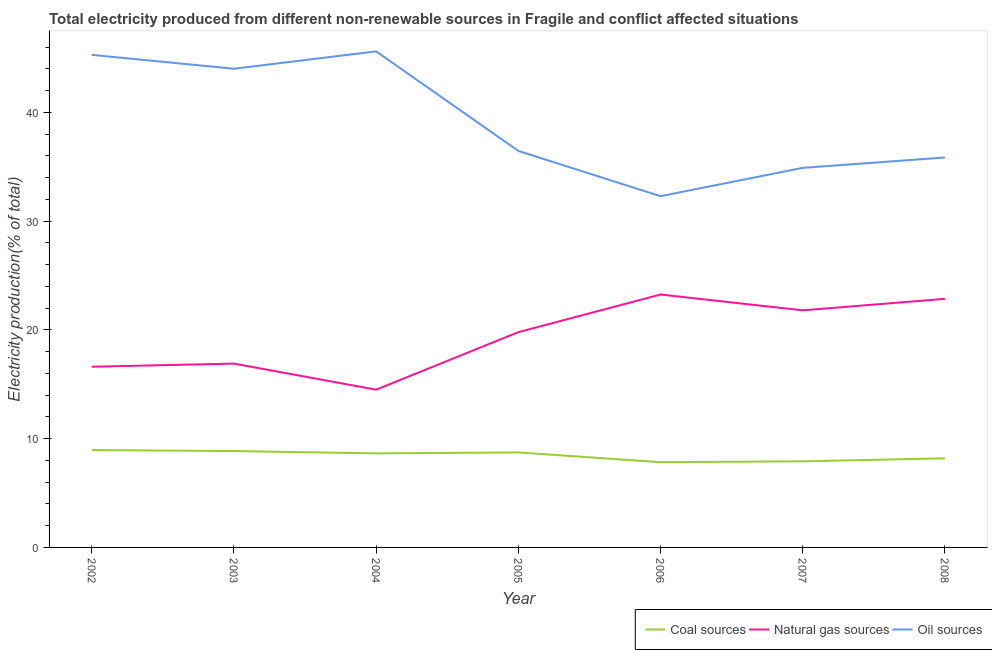What is the percentage of electricity produced by oil sources in 2004?
Give a very brief answer. 45.6. Across all years, what is the maximum percentage of electricity produced by coal?
Give a very brief answer. 8.95. Across all years, what is the minimum percentage of electricity produced by natural gas?
Offer a very short reply. 14.5. In which year was the percentage of electricity produced by natural gas minimum?
Offer a terse response. 2004. What is the total percentage of electricity produced by natural gas in the graph?
Your answer should be very brief. 135.7. What is the difference between the percentage of electricity produced by coal in 2003 and that in 2006?
Give a very brief answer. 1.02. What is the difference between the percentage of electricity produced by coal in 2008 and the percentage of electricity produced by natural gas in 2005?
Keep it short and to the point. -11.6. What is the average percentage of electricity produced by natural gas per year?
Offer a very short reply. 19.39. In the year 2003, what is the difference between the percentage of electricity produced by oil sources and percentage of electricity produced by coal?
Your answer should be very brief. 35.15. In how many years, is the percentage of electricity produced by coal greater than 30 %?
Your answer should be compact. 0. What is the ratio of the percentage of electricity produced by natural gas in 2005 to that in 2007?
Keep it short and to the point. 0.91. Is the percentage of electricity produced by coal in 2004 less than that in 2005?
Your answer should be very brief. Yes. Is the difference between the percentage of electricity produced by natural gas in 2003 and 2007 greater than the difference between the percentage of electricity produced by coal in 2003 and 2007?
Provide a succinct answer. No. What is the difference between the highest and the second highest percentage of electricity produced by coal?
Provide a short and direct response. 0.09. What is the difference between the highest and the lowest percentage of electricity produced by natural gas?
Keep it short and to the point. 8.75. In how many years, is the percentage of electricity produced by natural gas greater than the average percentage of electricity produced by natural gas taken over all years?
Keep it short and to the point. 4. Is it the case that in every year, the sum of the percentage of electricity produced by coal and percentage of electricity produced by natural gas is greater than the percentage of electricity produced by oil sources?
Offer a very short reply. No. Does the percentage of electricity produced by coal monotonically increase over the years?
Your answer should be compact. No. Is the percentage of electricity produced by natural gas strictly greater than the percentage of electricity produced by oil sources over the years?
Ensure brevity in your answer.  No. Is the percentage of electricity produced by natural gas strictly less than the percentage of electricity produced by coal over the years?
Your answer should be very brief. No. Does the graph contain any zero values?
Provide a succinct answer. No. What is the title of the graph?
Provide a short and direct response. Total electricity produced from different non-renewable sources in Fragile and conflict affected situations. What is the Electricity production(% of total) in Coal sources in 2002?
Offer a terse response. 8.95. What is the Electricity production(% of total) in Natural gas sources in 2002?
Keep it short and to the point. 16.61. What is the Electricity production(% of total) of Oil sources in 2002?
Your answer should be compact. 45.28. What is the Electricity production(% of total) in Coal sources in 2003?
Your answer should be compact. 8.86. What is the Electricity production(% of total) of Natural gas sources in 2003?
Offer a very short reply. 16.9. What is the Electricity production(% of total) in Oil sources in 2003?
Ensure brevity in your answer.  44.01. What is the Electricity production(% of total) in Coal sources in 2004?
Your answer should be compact. 8.65. What is the Electricity production(% of total) in Natural gas sources in 2004?
Offer a very short reply. 14.5. What is the Electricity production(% of total) of Oil sources in 2004?
Your answer should be very brief. 45.6. What is the Electricity production(% of total) of Coal sources in 2005?
Make the answer very short. 8.73. What is the Electricity production(% of total) of Natural gas sources in 2005?
Offer a terse response. 19.79. What is the Electricity production(% of total) in Oil sources in 2005?
Keep it short and to the point. 36.45. What is the Electricity production(% of total) in Coal sources in 2006?
Your answer should be compact. 7.84. What is the Electricity production(% of total) of Natural gas sources in 2006?
Give a very brief answer. 23.25. What is the Electricity production(% of total) of Oil sources in 2006?
Your answer should be very brief. 32.29. What is the Electricity production(% of total) in Coal sources in 2007?
Offer a very short reply. 7.91. What is the Electricity production(% of total) of Natural gas sources in 2007?
Provide a succinct answer. 21.8. What is the Electricity production(% of total) of Oil sources in 2007?
Ensure brevity in your answer.  34.89. What is the Electricity production(% of total) in Coal sources in 2008?
Provide a short and direct response. 8.19. What is the Electricity production(% of total) of Natural gas sources in 2008?
Make the answer very short. 22.85. What is the Electricity production(% of total) of Oil sources in 2008?
Your answer should be compact. 35.85. Across all years, what is the maximum Electricity production(% of total) of Coal sources?
Provide a short and direct response. 8.95. Across all years, what is the maximum Electricity production(% of total) of Natural gas sources?
Make the answer very short. 23.25. Across all years, what is the maximum Electricity production(% of total) of Oil sources?
Offer a very short reply. 45.6. Across all years, what is the minimum Electricity production(% of total) of Coal sources?
Provide a succinct answer. 7.84. Across all years, what is the minimum Electricity production(% of total) in Natural gas sources?
Provide a succinct answer. 14.5. Across all years, what is the minimum Electricity production(% of total) of Oil sources?
Your answer should be compact. 32.29. What is the total Electricity production(% of total) of Coal sources in the graph?
Offer a terse response. 59.14. What is the total Electricity production(% of total) of Natural gas sources in the graph?
Your response must be concise. 135.7. What is the total Electricity production(% of total) in Oil sources in the graph?
Give a very brief answer. 274.37. What is the difference between the Electricity production(% of total) in Coal sources in 2002 and that in 2003?
Offer a very short reply. 0.09. What is the difference between the Electricity production(% of total) of Natural gas sources in 2002 and that in 2003?
Give a very brief answer. -0.29. What is the difference between the Electricity production(% of total) in Oil sources in 2002 and that in 2003?
Provide a succinct answer. 1.28. What is the difference between the Electricity production(% of total) in Coal sources in 2002 and that in 2004?
Offer a very short reply. 0.3. What is the difference between the Electricity production(% of total) of Natural gas sources in 2002 and that in 2004?
Give a very brief answer. 2.11. What is the difference between the Electricity production(% of total) of Oil sources in 2002 and that in 2004?
Give a very brief answer. -0.32. What is the difference between the Electricity production(% of total) of Coal sources in 2002 and that in 2005?
Ensure brevity in your answer.  0.22. What is the difference between the Electricity production(% of total) in Natural gas sources in 2002 and that in 2005?
Your answer should be very brief. -3.18. What is the difference between the Electricity production(% of total) of Oil sources in 2002 and that in 2005?
Give a very brief answer. 8.83. What is the difference between the Electricity production(% of total) in Coal sources in 2002 and that in 2006?
Your answer should be very brief. 1.11. What is the difference between the Electricity production(% of total) in Natural gas sources in 2002 and that in 2006?
Offer a terse response. -6.64. What is the difference between the Electricity production(% of total) in Oil sources in 2002 and that in 2006?
Give a very brief answer. 12.99. What is the difference between the Electricity production(% of total) in Coal sources in 2002 and that in 2007?
Offer a terse response. 1.04. What is the difference between the Electricity production(% of total) of Natural gas sources in 2002 and that in 2007?
Offer a terse response. -5.18. What is the difference between the Electricity production(% of total) in Oil sources in 2002 and that in 2007?
Offer a very short reply. 10.39. What is the difference between the Electricity production(% of total) of Coal sources in 2002 and that in 2008?
Provide a succinct answer. 0.76. What is the difference between the Electricity production(% of total) in Natural gas sources in 2002 and that in 2008?
Offer a terse response. -6.24. What is the difference between the Electricity production(% of total) of Oil sources in 2002 and that in 2008?
Provide a succinct answer. 9.43. What is the difference between the Electricity production(% of total) in Coal sources in 2003 and that in 2004?
Ensure brevity in your answer.  0.21. What is the difference between the Electricity production(% of total) in Natural gas sources in 2003 and that in 2004?
Ensure brevity in your answer.  2.4. What is the difference between the Electricity production(% of total) in Oil sources in 2003 and that in 2004?
Provide a short and direct response. -1.6. What is the difference between the Electricity production(% of total) of Coal sources in 2003 and that in 2005?
Provide a succinct answer. 0.13. What is the difference between the Electricity production(% of total) of Natural gas sources in 2003 and that in 2005?
Make the answer very short. -2.89. What is the difference between the Electricity production(% of total) of Oil sources in 2003 and that in 2005?
Your response must be concise. 7.56. What is the difference between the Electricity production(% of total) in Natural gas sources in 2003 and that in 2006?
Make the answer very short. -6.35. What is the difference between the Electricity production(% of total) in Oil sources in 2003 and that in 2006?
Keep it short and to the point. 11.72. What is the difference between the Electricity production(% of total) of Coal sources in 2003 and that in 2007?
Provide a short and direct response. 0.94. What is the difference between the Electricity production(% of total) in Natural gas sources in 2003 and that in 2007?
Make the answer very short. -4.9. What is the difference between the Electricity production(% of total) in Oil sources in 2003 and that in 2007?
Provide a short and direct response. 9.11. What is the difference between the Electricity production(% of total) of Coal sources in 2003 and that in 2008?
Give a very brief answer. 0.67. What is the difference between the Electricity production(% of total) of Natural gas sources in 2003 and that in 2008?
Make the answer very short. -5.95. What is the difference between the Electricity production(% of total) in Oil sources in 2003 and that in 2008?
Keep it short and to the point. 8.16. What is the difference between the Electricity production(% of total) of Coal sources in 2004 and that in 2005?
Ensure brevity in your answer.  -0.08. What is the difference between the Electricity production(% of total) of Natural gas sources in 2004 and that in 2005?
Offer a very short reply. -5.29. What is the difference between the Electricity production(% of total) in Oil sources in 2004 and that in 2005?
Your answer should be very brief. 9.15. What is the difference between the Electricity production(% of total) in Coal sources in 2004 and that in 2006?
Offer a terse response. 0.81. What is the difference between the Electricity production(% of total) of Natural gas sources in 2004 and that in 2006?
Keep it short and to the point. -8.75. What is the difference between the Electricity production(% of total) in Oil sources in 2004 and that in 2006?
Provide a short and direct response. 13.31. What is the difference between the Electricity production(% of total) in Coal sources in 2004 and that in 2007?
Provide a succinct answer. 0.73. What is the difference between the Electricity production(% of total) of Natural gas sources in 2004 and that in 2007?
Your response must be concise. -7.29. What is the difference between the Electricity production(% of total) in Oil sources in 2004 and that in 2007?
Offer a terse response. 10.71. What is the difference between the Electricity production(% of total) in Coal sources in 2004 and that in 2008?
Make the answer very short. 0.46. What is the difference between the Electricity production(% of total) in Natural gas sources in 2004 and that in 2008?
Keep it short and to the point. -8.35. What is the difference between the Electricity production(% of total) in Oil sources in 2004 and that in 2008?
Offer a very short reply. 9.76. What is the difference between the Electricity production(% of total) of Coal sources in 2005 and that in 2006?
Offer a very short reply. 0.89. What is the difference between the Electricity production(% of total) in Natural gas sources in 2005 and that in 2006?
Your response must be concise. -3.46. What is the difference between the Electricity production(% of total) in Oil sources in 2005 and that in 2006?
Offer a terse response. 4.16. What is the difference between the Electricity production(% of total) of Coal sources in 2005 and that in 2007?
Offer a terse response. 0.82. What is the difference between the Electricity production(% of total) in Natural gas sources in 2005 and that in 2007?
Provide a short and direct response. -2.01. What is the difference between the Electricity production(% of total) in Oil sources in 2005 and that in 2007?
Provide a short and direct response. 1.56. What is the difference between the Electricity production(% of total) in Coal sources in 2005 and that in 2008?
Ensure brevity in your answer.  0.54. What is the difference between the Electricity production(% of total) in Natural gas sources in 2005 and that in 2008?
Keep it short and to the point. -3.06. What is the difference between the Electricity production(% of total) of Oil sources in 2005 and that in 2008?
Your answer should be compact. 0.6. What is the difference between the Electricity production(% of total) in Coal sources in 2006 and that in 2007?
Provide a short and direct response. -0.08. What is the difference between the Electricity production(% of total) of Natural gas sources in 2006 and that in 2007?
Offer a very short reply. 1.45. What is the difference between the Electricity production(% of total) of Oil sources in 2006 and that in 2007?
Your response must be concise. -2.6. What is the difference between the Electricity production(% of total) in Coal sources in 2006 and that in 2008?
Provide a short and direct response. -0.35. What is the difference between the Electricity production(% of total) of Natural gas sources in 2006 and that in 2008?
Your answer should be compact. 0.4. What is the difference between the Electricity production(% of total) of Oil sources in 2006 and that in 2008?
Your response must be concise. -3.56. What is the difference between the Electricity production(% of total) in Coal sources in 2007 and that in 2008?
Your response must be concise. -0.28. What is the difference between the Electricity production(% of total) of Natural gas sources in 2007 and that in 2008?
Ensure brevity in your answer.  -1.05. What is the difference between the Electricity production(% of total) of Oil sources in 2007 and that in 2008?
Keep it short and to the point. -0.95. What is the difference between the Electricity production(% of total) in Coal sources in 2002 and the Electricity production(% of total) in Natural gas sources in 2003?
Provide a succinct answer. -7.95. What is the difference between the Electricity production(% of total) of Coal sources in 2002 and the Electricity production(% of total) of Oil sources in 2003?
Ensure brevity in your answer.  -35.05. What is the difference between the Electricity production(% of total) of Natural gas sources in 2002 and the Electricity production(% of total) of Oil sources in 2003?
Your answer should be very brief. -27.39. What is the difference between the Electricity production(% of total) in Coal sources in 2002 and the Electricity production(% of total) in Natural gas sources in 2004?
Provide a succinct answer. -5.55. What is the difference between the Electricity production(% of total) in Coal sources in 2002 and the Electricity production(% of total) in Oil sources in 2004?
Ensure brevity in your answer.  -36.65. What is the difference between the Electricity production(% of total) of Natural gas sources in 2002 and the Electricity production(% of total) of Oil sources in 2004?
Offer a very short reply. -28.99. What is the difference between the Electricity production(% of total) in Coal sources in 2002 and the Electricity production(% of total) in Natural gas sources in 2005?
Your response must be concise. -10.84. What is the difference between the Electricity production(% of total) of Coal sources in 2002 and the Electricity production(% of total) of Oil sources in 2005?
Offer a terse response. -27.5. What is the difference between the Electricity production(% of total) of Natural gas sources in 2002 and the Electricity production(% of total) of Oil sources in 2005?
Keep it short and to the point. -19.84. What is the difference between the Electricity production(% of total) of Coal sources in 2002 and the Electricity production(% of total) of Natural gas sources in 2006?
Your answer should be very brief. -14.3. What is the difference between the Electricity production(% of total) of Coal sources in 2002 and the Electricity production(% of total) of Oil sources in 2006?
Your response must be concise. -23.34. What is the difference between the Electricity production(% of total) in Natural gas sources in 2002 and the Electricity production(% of total) in Oil sources in 2006?
Your answer should be compact. -15.68. What is the difference between the Electricity production(% of total) of Coal sources in 2002 and the Electricity production(% of total) of Natural gas sources in 2007?
Give a very brief answer. -12.85. What is the difference between the Electricity production(% of total) of Coal sources in 2002 and the Electricity production(% of total) of Oil sources in 2007?
Your response must be concise. -25.94. What is the difference between the Electricity production(% of total) in Natural gas sources in 2002 and the Electricity production(% of total) in Oil sources in 2007?
Offer a very short reply. -18.28. What is the difference between the Electricity production(% of total) of Coal sources in 2002 and the Electricity production(% of total) of Natural gas sources in 2008?
Provide a short and direct response. -13.9. What is the difference between the Electricity production(% of total) in Coal sources in 2002 and the Electricity production(% of total) in Oil sources in 2008?
Your answer should be very brief. -26.9. What is the difference between the Electricity production(% of total) of Natural gas sources in 2002 and the Electricity production(% of total) of Oil sources in 2008?
Give a very brief answer. -19.23. What is the difference between the Electricity production(% of total) in Coal sources in 2003 and the Electricity production(% of total) in Natural gas sources in 2004?
Your answer should be very brief. -5.64. What is the difference between the Electricity production(% of total) in Coal sources in 2003 and the Electricity production(% of total) in Oil sources in 2004?
Your answer should be very brief. -36.74. What is the difference between the Electricity production(% of total) of Natural gas sources in 2003 and the Electricity production(% of total) of Oil sources in 2004?
Your answer should be compact. -28.7. What is the difference between the Electricity production(% of total) of Coal sources in 2003 and the Electricity production(% of total) of Natural gas sources in 2005?
Your response must be concise. -10.93. What is the difference between the Electricity production(% of total) of Coal sources in 2003 and the Electricity production(% of total) of Oil sources in 2005?
Offer a very short reply. -27.59. What is the difference between the Electricity production(% of total) in Natural gas sources in 2003 and the Electricity production(% of total) in Oil sources in 2005?
Your response must be concise. -19.55. What is the difference between the Electricity production(% of total) of Coal sources in 2003 and the Electricity production(% of total) of Natural gas sources in 2006?
Offer a terse response. -14.39. What is the difference between the Electricity production(% of total) in Coal sources in 2003 and the Electricity production(% of total) in Oil sources in 2006?
Ensure brevity in your answer.  -23.43. What is the difference between the Electricity production(% of total) in Natural gas sources in 2003 and the Electricity production(% of total) in Oil sources in 2006?
Ensure brevity in your answer.  -15.39. What is the difference between the Electricity production(% of total) of Coal sources in 2003 and the Electricity production(% of total) of Natural gas sources in 2007?
Offer a very short reply. -12.94. What is the difference between the Electricity production(% of total) of Coal sources in 2003 and the Electricity production(% of total) of Oil sources in 2007?
Keep it short and to the point. -26.03. What is the difference between the Electricity production(% of total) of Natural gas sources in 2003 and the Electricity production(% of total) of Oil sources in 2007?
Provide a short and direct response. -17.99. What is the difference between the Electricity production(% of total) of Coal sources in 2003 and the Electricity production(% of total) of Natural gas sources in 2008?
Give a very brief answer. -13.99. What is the difference between the Electricity production(% of total) of Coal sources in 2003 and the Electricity production(% of total) of Oil sources in 2008?
Ensure brevity in your answer.  -26.99. What is the difference between the Electricity production(% of total) of Natural gas sources in 2003 and the Electricity production(% of total) of Oil sources in 2008?
Provide a short and direct response. -18.95. What is the difference between the Electricity production(% of total) of Coal sources in 2004 and the Electricity production(% of total) of Natural gas sources in 2005?
Ensure brevity in your answer.  -11.14. What is the difference between the Electricity production(% of total) of Coal sources in 2004 and the Electricity production(% of total) of Oil sources in 2005?
Your answer should be very brief. -27.8. What is the difference between the Electricity production(% of total) of Natural gas sources in 2004 and the Electricity production(% of total) of Oil sources in 2005?
Provide a succinct answer. -21.95. What is the difference between the Electricity production(% of total) of Coal sources in 2004 and the Electricity production(% of total) of Natural gas sources in 2006?
Make the answer very short. -14.6. What is the difference between the Electricity production(% of total) of Coal sources in 2004 and the Electricity production(% of total) of Oil sources in 2006?
Ensure brevity in your answer.  -23.64. What is the difference between the Electricity production(% of total) of Natural gas sources in 2004 and the Electricity production(% of total) of Oil sources in 2006?
Provide a succinct answer. -17.79. What is the difference between the Electricity production(% of total) of Coal sources in 2004 and the Electricity production(% of total) of Natural gas sources in 2007?
Offer a terse response. -13.15. What is the difference between the Electricity production(% of total) of Coal sources in 2004 and the Electricity production(% of total) of Oil sources in 2007?
Offer a very short reply. -26.25. What is the difference between the Electricity production(% of total) in Natural gas sources in 2004 and the Electricity production(% of total) in Oil sources in 2007?
Ensure brevity in your answer.  -20.39. What is the difference between the Electricity production(% of total) in Coal sources in 2004 and the Electricity production(% of total) in Natural gas sources in 2008?
Provide a short and direct response. -14.2. What is the difference between the Electricity production(% of total) in Coal sources in 2004 and the Electricity production(% of total) in Oil sources in 2008?
Provide a succinct answer. -27.2. What is the difference between the Electricity production(% of total) of Natural gas sources in 2004 and the Electricity production(% of total) of Oil sources in 2008?
Provide a succinct answer. -21.35. What is the difference between the Electricity production(% of total) in Coal sources in 2005 and the Electricity production(% of total) in Natural gas sources in 2006?
Provide a succinct answer. -14.52. What is the difference between the Electricity production(% of total) of Coal sources in 2005 and the Electricity production(% of total) of Oil sources in 2006?
Provide a short and direct response. -23.56. What is the difference between the Electricity production(% of total) in Natural gas sources in 2005 and the Electricity production(% of total) in Oil sources in 2006?
Offer a terse response. -12.5. What is the difference between the Electricity production(% of total) in Coal sources in 2005 and the Electricity production(% of total) in Natural gas sources in 2007?
Offer a very short reply. -13.06. What is the difference between the Electricity production(% of total) of Coal sources in 2005 and the Electricity production(% of total) of Oil sources in 2007?
Ensure brevity in your answer.  -26.16. What is the difference between the Electricity production(% of total) in Natural gas sources in 2005 and the Electricity production(% of total) in Oil sources in 2007?
Offer a very short reply. -15.1. What is the difference between the Electricity production(% of total) of Coal sources in 2005 and the Electricity production(% of total) of Natural gas sources in 2008?
Keep it short and to the point. -14.12. What is the difference between the Electricity production(% of total) of Coal sources in 2005 and the Electricity production(% of total) of Oil sources in 2008?
Keep it short and to the point. -27.11. What is the difference between the Electricity production(% of total) of Natural gas sources in 2005 and the Electricity production(% of total) of Oil sources in 2008?
Offer a terse response. -16.06. What is the difference between the Electricity production(% of total) of Coal sources in 2006 and the Electricity production(% of total) of Natural gas sources in 2007?
Your answer should be compact. -13.96. What is the difference between the Electricity production(% of total) in Coal sources in 2006 and the Electricity production(% of total) in Oil sources in 2007?
Give a very brief answer. -27.06. What is the difference between the Electricity production(% of total) of Natural gas sources in 2006 and the Electricity production(% of total) of Oil sources in 2007?
Your response must be concise. -11.64. What is the difference between the Electricity production(% of total) in Coal sources in 2006 and the Electricity production(% of total) in Natural gas sources in 2008?
Your answer should be very brief. -15.01. What is the difference between the Electricity production(% of total) in Coal sources in 2006 and the Electricity production(% of total) in Oil sources in 2008?
Your answer should be very brief. -28.01. What is the difference between the Electricity production(% of total) in Natural gas sources in 2006 and the Electricity production(% of total) in Oil sources in 2008?
Provide a short and direct response. -12.6. What is the difference between the Electricity production(% of total) of Coal sources in 2007 and the Electricity production(% of total) of Natural gas sources in 2008?
Keep it short and to the point. -14.94. What is the difference between the Electricity production(% of total) of Coal sources in 2007 and the Electricity production(% of total) of Oil sources in 2008?
Give a very brief answer. -27.93. What is the difference between the Electricity production(% of total) in Natural gas sources in 2007 and the Electricity production(% of total) in Oil sources in 2008?
Keep it short and to the point. -14.05. What is the average Electricity production(% of total) in Coal sources per year?
Provide a short and direct response. 8.45. What is the average Electricity production(% of total) in Natural gas sources per year?
Offer a very short reply. 19.39. What is the average Electricity production(% of total) of Oil sources per year?
Provide a succinct answer. 39.2. In the year 2002, what is the difference between the Electricity production(% of total) of Coal sources and Electricity production(% of total) of Natural gas sources?
Give a very brief answer. -7.66. In the year 2002, what is the difference between the Electricity production(% of total) in Coal sources and Electricity production(% of total) in Oil sources?
Offer a very short reply. -36.33. In the year 2002, what is the difference between the Electricity production(% of total) of Natural gas sources and Electricity production(% of total) of Oil sources?
Offer a terse response. -28.67. In the year 2003, what is the difference between the Electricity production(% of total) in Coal sources and Electricity production(% of total) in Natural gas sources?
Make the answer very short. -8.04. In the year 2003, what is the difference between the Electricity production(% of total) in Coal sources and Electricity production(% of total) in Oil sources?
Offer a terse response. -35.15. In the year 2003, what is the difference between the Electricity production(% of total) of Natural gas sources and Electricity production(% of total) of Oil sources?
Ensure brevity in your answer.  -27.11. In the year 2004, what is the difference between the Electricity production(% of total) in Coal sources and Electricity production(% of total) in Natural gas sources?
Your response must be concise. -5.85. In the year 2004, what is the difference between the Electricity production(% of total) of Coal sources and Electricity production(% of total) of Oil sources?
Give a very brief answer. -36.95. In the year 2004, what is the difference between the Electricity production(% of total) of Natural gas sources and Electricity production(% of total) of Oil sources?
Provide a succinct answer. -31.1. In the year 2005, what is the difference between the Electricity production(% of total) in Coal sources and Electricity production(% of total) in Natural gas sources?
Your response must be concise. -11.06. In the year 2005, what is the difference between the Electricity production(% of total) in Coal sources and Electricity production(% of total) in Oil sources?
Provide a succinct answer. -27.72. In the year 2005, what is the difference between the Electricity production(% of total) of Natural gas sources and Electricity production(% of total) of Oil sources?
Ensure brevity in your answer.  -16.66. In the year 2006, what is the difference between the Electricity production(% of total) of Coal sources and Electricity production(% of total) of Natural gas sources?
Provide a succinct answer. -15.41. In the year 2006, what is the difference between the Electricity production(% of total) of Coal sources and Electricity production(% of total) of Oil sources?
Make the answer very short. -24.45. In the year 2006, what is the difference between the Electricity production(% of total) in Natural gas sources and Electricity production(% of total) in Oil sources?
Offer a very short reply. -9.04. In the year 2007, what is the difference between the Electricity production(% of total) in Coal sources and Electricity production(% of total) in Natural gas sources?
Ensure brevity in your answer.  -13.88. In the year 2007, what is the difference between the Electricity production(% of total) in Coal sources and Electricity production(% of total) in Oil sources?
Provide a short and direct response. -26.98. In the year 2007, what is the difference between the Electricity production(% of total) of Natural gas sources and Electricity production(% of total) of Oil sources?
Provide a short and direct response. -13.1. In the year 2008, what is the difference between the Electricity production(% of total) in Coal sources and Electricity production(% of total) in Natural gas sources?
Your answer should be compact. -14.66. In the year 2008, what is the difference between the Electricity production(% of total) in Coal sources and Electricity production(% of total) in Oil sources?
Give a very brief answer. -27.66. In the year 2008, what is the difference between the Electricity production(% of total) in Natural gas sources and Electricity production(% of total) in Oil sources?
Make the answer very short. -13. What is the ratio of the Electricity production(% of total) in Coal sources in 2002 to that in 2003?
Your answer should be compact. 1.01. What is the ratio of the Electricity production(% of total) of Natural gas sources in 2002 to that in 2003?
Provide a short and direct response. 0.98. What is the ratio of the Electricity production(% of total) in Oil sources in 2002 to that in 2003?
Provide a succinct answer. 1.03. What is the ratio of the Electricity production(% of total) of Coal sources in 2002 to that in 2004?
Your response must be concise. 1.04. What is the ratio of the Electricity production(% of total) in Natural gas sources in 2002 to that in 2004?
Your answer should be compact. 1.15. What is the ratio of the Electricity production(% of total) of Oil sources in 2002 to that in 2004?
Offer a very short reply. 0.99. What is the ratio of the Electricity production(% of total) in Coal sources in 2002 to that in 2005?
Keep it short and to the point. 1.03. What is the ratio of the Electricity production(% of total) of Natural gas sources in 2002 to that in 2005?
Provide a succinct answer. 0.84. What is the ratio of the Electricity production(% of total) in Oil sources in 2002 to that in 2005?
Your answer should be very brief. 1.24. What is the ratio of the Electricity production(% of total) in Coal sources in 2002 to that in 2006?
Provide a short and direct response. 1.14. What is the ratio of the Electricity production(% of total) in Natural gas sources in 2002 to that in 2006?
Offer a very short reply. 0.71. What is the ratio of the Electricity production(% of total) in Oil sources in 2002 to that in 2006?
Ensure brevity in your answer.  1.4. What is the ratio of the Electricity production(% of total) of Coal sources in 2002 to that in 2007?
Provide a short and direct response. 1.13. What is the ratio of the Electricity production(% of total) of Natural gas sources in 2002 to that in 2007?
Offer a very short reply. 0.76. What is the ratio of the Electricity production(% of total) in Oil sources in 2002 to that in 2007?
Your response must be concise. 1.3. What is the ratio of the Electricity production(% of total) of Coal sources in 2002 to that in 2008?
Your response must be concise. 1.09. What is the ratio of the Electricity production(% of total) in Natural gas sources in 2002 to that in 2008?
Give a very brief answer. 0.73. What is the ratio of the Electricity production(% of total) in Oil sources in 2002 to that in 2008?
Offer a terse response. 1.26. What is the ratio of the Electricity production(% of total) in Coal sources in 2003 to that in 2004?
Provide a short and direct response. 1.02. What is the ratio of the Electricity production(% of total) in Natural gas sources in 2003 to that in 2004?
Offer a terse response. 1.17. What is the ratio of the Electricity production(% of total) of Oil sources in 2003 to that in 2004?
Offer a terse response. 0.96. What is the ratio of the Electricity production(% of total) in Coal sources in 2003 to that in 2005?
Provide a succinct answer. 1.01. What is the ratio of the Electricity production(% of total) of Natural gas sources in 2003 to that in 2005?
Your response must be concise. 0.85. What is the ratio of the Electricity production(% of total) in Oil sources in 2003 to that in 2005?
Give a very brief answer. 1.21. What is the ratio of the Electricity production(% of total) in Coal sources in 2003 to that in 2006?
Your answer should be very brief. 1.13. What is the ratio of the Electricity production(% of total) of Natural gas sources in 2003 to that in 2006?
Ensure brevity in your answer.  0.73. What is the ratio of the Electricity production(% of total) in Oil sources in 2003 to that in 2006?
Provide a succinct answer. 1.36. What is the ratio of the Electricity production(% of total) in Coal sources in 2003 to that in 2007?
Ensure brevity in your answer.  1.12. What is the ratio of the Electricity production(% of total) of Natural gas sources in 2003 to that in 2007?
Offer a terse response. 0.78. What is the ratio of the Electricity production(% of total) of Oil sources in 2003 to that in 2007?
Provide a short and direct response. 1.26. What is the ratio of the Electricity production(% of total) in Coal sources in 2003 to that in 2008?
Your answer should be very brief. 1.08. What is the ratio of the Electricity production(% of total) in Natural gas sources in 2003 to that in 2008?
Your answer should be compact. 0.74. What is the ratio of the Electricity production(% of total) of Oil sources in 2003 to that in 2008?
Make the answer very short. 1.23. What is the ratio of the Electricity production(% of total) in Natural gas sources in 2004 to that in 2005?
Give a very brief answer. 0.73. What is the ratio of the Electricity production(% of total) of Oil sources in 2004 to that in 2005?
Offer a terse response. 1.25. What is the ratio of the Electricity production(% of total) of Coal sources in 2004 to that in 2006?
Give a very brief answer. 1.1. What is the ratio of the Electricity production(% of total) in Natural gas sources in 2004 to that in 2006?
Your answer should be very brief. 0.62. What is the ratio of the Electricity production(% of total) of Oil sources in 2004 to that in 2006?
Ensure brevity in your answer.  1.41. What is the ratio of the Electricity production(% of total) in Coal sources in 2004 to that in 2007?
Give a very brief answer. 1.09. What is the ratio of the Electricity production(% of total) in Natural gas sources in 2004 to that in 2007?
Your answer should be compact. 0.67. What is the ratio of the Electricity production(% of total) in Oil sources in 2004 to that in 2007?
Your response must be concise. 1.31. What is the ratio of the Electricity production(% of total) in Coal sources in 2004 to that in 2008?
Offer a very short reply. 1.06. What is the ratio of the Electricity production(% of total) of Natural gas sources in 2004 to that in 2008?
Provide a succinct answer. 0.63. What is the ratio of the Electricity production(% of total) in Oil sources in 2004 to that in 2008?
Make the answer very short. 1.27. What is the ratio of the Electricity production(% of total) in Coal sources in 2005 to that in 2006?
Ensure brevity in your answer.  1.11. What is the ratio of the Electricity production(% of total) of Natural gas sources in 2005 to that in 2006?
Make the answer very short. 0.85. What is the ratio of the Electricity production(% of total) of Oil sources in 2005 to that in 2006?
Offer a terse response. 1.13. What is the ratio of the Electricity production(% of total) in Coal sources in 2005 to that in 2007?
Make the answer very short. 1.1. What is the ratio of the Electricity production(% of total) in Natural gas sources in 2005 to that in 2007?
Make the answer very short. 0.91. What is the ratio of the Electricity production(% of total) of Oil sources in 2005 to that in 2007?
Your answer should be compact. 1.04. What is the ratio of the Electricity production(% of total) of Coal sources in 2005 to that in 2008?
Offer a very short reply. 1.07. What is the ratio of the Electricity production(% of total) in Natural gas sources in 2005 to that in 2008?
Offer a terse response. 0.87. What is the ratio of the Electricity production(% of total) of Oil sources in 2005 to that in 2008?
Keep it short and to the point. 1.02. What is the ratio of the Electricity production(% of total) of Coal sources in 2006 to that in 2007?
Give a very brief answer. 0.99. What is the ratio of the Electricity production(% of total) in Natural gas sources in 2006 to that in 2007?
Provide a succinct answer. 1.07. What is the ratio of the Electricity production(% of total) of Oil sources in 2006 to that in 2007?
Offer a terse response. 0.93. What is the ratio of the Electricity production(% of total) of Coal sources in 2006 to that in 2008?
Provide a succinct answer. 0.96. What is the ratio of the Electricity production(% of total) of Natural gas sources in 2006 to that in 2008?
Make the answer very short. 1.02. What is the ratio of the Electricity production(% of total) of Oil sources in 2006 to that in 2008?
Make the answer very short. 0.9. What is the ratio of the Electricity production(% of total) of Coal sources in 2007 to that in 2008?
Your answer should be compact. 0.97. What is the ratio of the Electricity production(% of total) in Natural gas sources in 2007 to that in 2008?
Your answer should be very brief. 0.95. What is the ratio of the Electricity production(% of total) of Oil sources in 2007 to that in 2008?
Offer a terse response. 0.97. What is the difference between the highest and the second highest Electricity production(% of total) in Coal sources?
Offer a terse response. 0.09. What is the difference between the highest and the second highest Electricity production(% of total) in Natural gas sources?
Offer a very short reply. 0.4. What is the difference between the highest and the second highest Electricity production(% of total) in Oil sources?
Provide a short and direct response. 0.32. What is the difference between the highest and the lowest Electricity production(% of total) in Coal sources?
Offer a terse response. 1.11. What is the difference between the highest and the lowest Electricity production(% of total) of Natural gas sources?
Your answer should be compact. 8.75. What is the difference between the highest and the lowest Electricity production(% of total) of Oil sources?
Give a very brief answer. 13.31. 